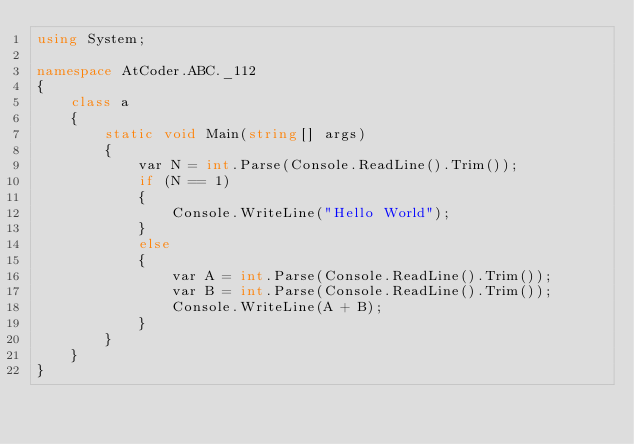<code> <loc_0><loc_0><loc_500><loc_500><_C#_>using System;

namespace AtCoder.ABC._112
{
    class a
    {
        static void Main(string[] args)
        {
            var N = int.Parse(Console.ReadLine().Trim());
            if (N == 1)
            {
                Console.WriteLine("Hello World");
            }
            else
            {
                var A = int.Parse(Console.ReadLine().Trim());
                var B = int.Parse(Console.ReadLine().Trim());
                Console.WriteLine(A + B);
            }
        }
    }
}
</code> 